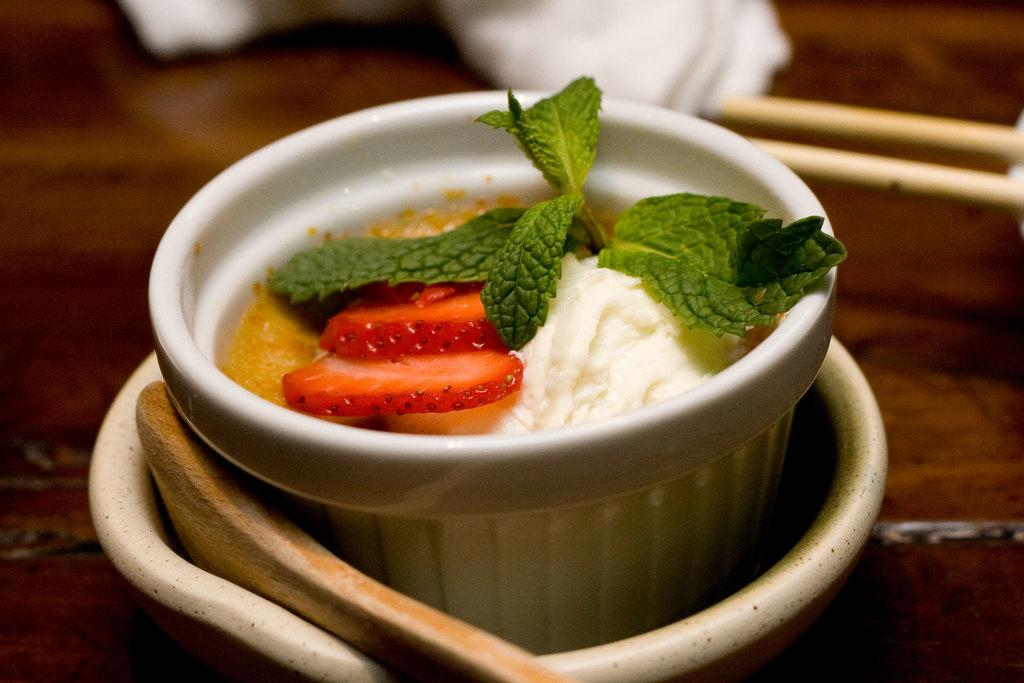What is in the bowl that is visible in the image? There is a bowl of food item in the image. What utensil is present in the image? There is a spoon in the image. What type of surface is visible in the image? The wooden surface is present in the image. What type of arch can be seen in the image? There is no arch present in the image. 